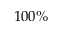<formula> <loc_0><loc_0><loc_500><loc_500>1 0 0 \%</formula> 